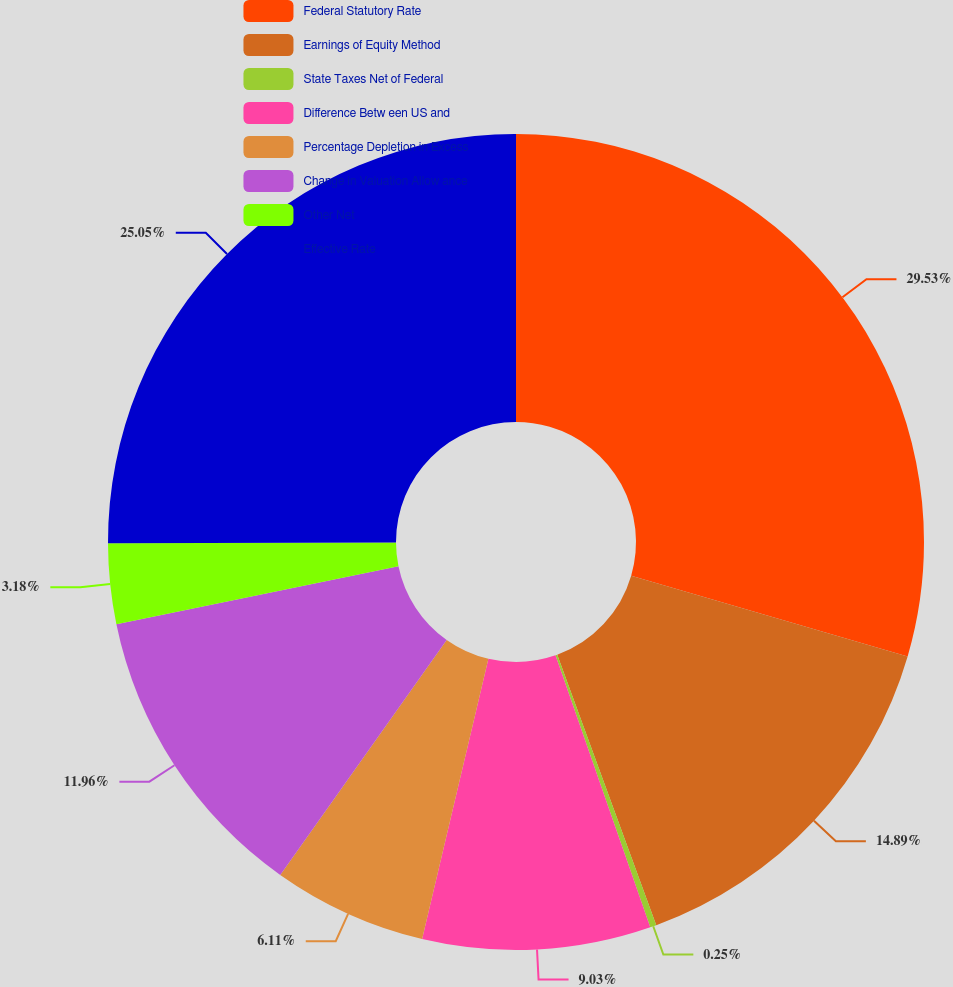Convert chart. <chart><loc_0><loc_0><loc_500><loc_500><pie_chart><fcel>Federal Statutory Rate<fcel>Earnings of Equity Method<fcel>State Taxes Net of Federal<fcel>Difference Betw een US and<fcel>Percentage Depletion in Excess<fcel>Change in Valuation Allow ance<fcel>Other Net<fcel>Effective Rate<nl><fcel>29.52%<fcel>14.89%<fcel>0.25%<fcel>9.03%<fcel>6.11%<fcel>11.96%<fcel>3.18%<fcel>25.05%<nl></chart> 